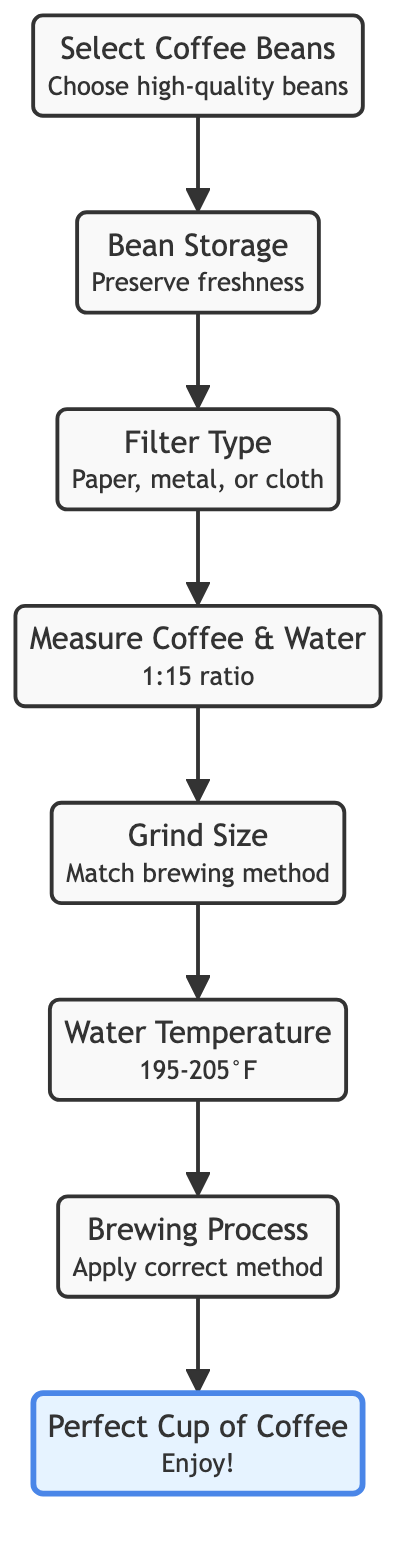What is the final step in the coffee brewing routine? The final step in the flowchart represents the ultimate goal of the coffee brewing routine, which is "Perfect Cup of Coffee". This is the last node in the diagram and reflects the result of all preceding steps.
Answer: Perfect Cup of Coffee How many nodes are there in the diagram? By counting the distinct steps from "Select Coffee Beans" to "Perfect Cup of Coffee", there are a total of 8 nodes represented in the flowchart, including the final cup.
Answer: 8 What is the second step in the coffee brewing process? The flowchart shows the steps in order where the first step is "Select Coffee Beans". Following that, the second step is "Bean Storage", which is the next node connected to the first.
Answer: Bean Storage Which step requires the coffee-to-water ratio? The flowchart indicates that the step focusing on the correct coffee-to-water ratio is labeled "Measure Coffee & Water". This step directly follows the selection of the filter type.
Answer: Measure Coffee & Water What comes after selecting a suitable filter? In the flowchart, after "Filter Type", the next process is "Measure Coffee & Water". This sequential relationship indicates that measuring takes place next.
Answer: Measure Coffee & Water What is the purpose of "Grind Size" in the process? The "Grind Size" node signifies the importance of adjusting the coffee grind size based on the chosen brewing method. This step is crucial for achieving optimal extraction.
Answer: Match brewing method How does "Bean Storage" influence the final cup? "Bean Storage" plays a vital role in maintaining the freshness of the coffee beans, which ultimately affects the overall quality and taste of the "Perfect Cup of Coffee" that is produced at the end.
Answer: Preserves freshness What temperature range should the water be heated to? The diagram explicitly marks the ideal temperature for water as being between 195-205°F in the "Water Temperature" step, underscoring its significance in the brewing process for optimal flavor extraction.
Answer: 195-205°F What is the relationship between 'Measure Coffee & Water' and 'Grind Size'? The "Measure Coffee & Water" step logically leads to the "Grind Size" step, indicating that after determining the coffee-to-water ratio, the next critical decision involves selecting the appropriate grind size based on the brewing method.
Answer: Sequential connection 